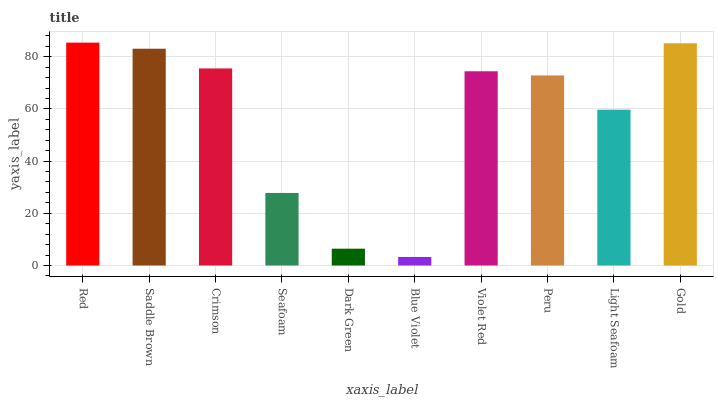Is Blue Violet the minimum?
Answer yes or no. Yes. Is Red the maximum?
Answer yes or no. Yes. Is Saddle Brown the minimum?
Answer yes or no. No. Is Saddle Brown the maximum?
Answer yes or no. No. Is Red greater than Saddle Brown?
Answer yes or no. Yes. Is Saddle Brown less than Red?
Answer yes or no. Yes. Is Saddle Brown greater than Red?
Answer yes or no. No. Is Red less than Saddle Brown?
Answer yes or no. No. Is Violet Red the high median?
Answer yes or no. Yes. Is Peru the low median?
Answer yes or no. Yes. Is Gold the high median?
Answer yes or no. No. Is Seafoam the low median?
Answer yes or no. No. 